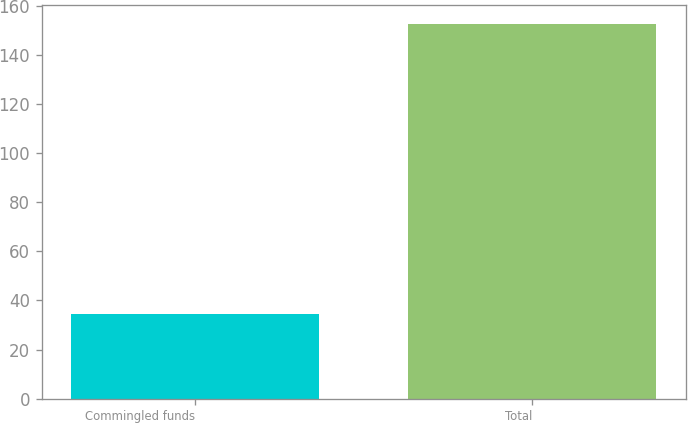<chart> <loc_0><loc_0><loc_500><loc_500><bar_chart><fcel>Commingled funds<fcel>Total<nl><fcel>34.5<fcel>152.7<nl></chart> 